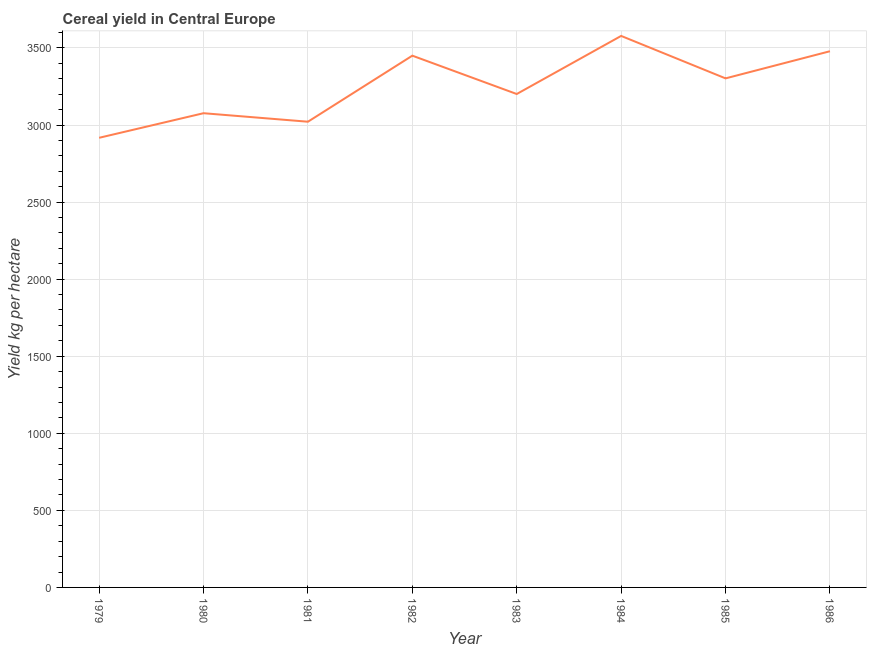What is the cereal yield in 1984?
Your answer should be very brief. 3578.03. Across all years, what is the maximum cereal yield?
Offer a very short reply. 3578.03. Across all years, what is the minimum cereal yield?
Your answer should be very brief. 2917.08. In which year was the cereal yield maximum?
Provide a succinct answer. 1984. In which year was the cereal yield minimum?
Your response must be concise. 1979. What is the sum of the cereal yield?
Make the answer very short. 2.60e+04. What is the difference between the cereal yield in 1983 and 1984?
Provide a short and direct response. -376.89. What is the average cereal yield per year?
Give a very brief answer. 3253.16. What is the median cereal yield?
Your response must be concise. 3251.85. What is the ratio of the cereal yield in 1981 to that in 1986?
Your answer should be compact. 0.87. Is the cereal yield in 1983 less than that in 1986?
Offer a terse response. Yes. What is the difference between the highest and the second highest cereal yield?
Ensure brevity in your answer.  99.38. What is the difference between the highest and the lowest cereal yield?
Give a very brief answer. 660.95. In how many years, is the cereal yield greater than the average cereal yield taken over all years?
Provide a succinct answer. 4. How many years are there in the graph?
Provide a succinct answer. 8. What is the difference between two consecutive major ticks on the Y-axis?
Give a very brief answer. 500. Does the graph contain grids?
Your answer should be very brief. Yes. What is the title of the graph?
Offer a terse response. Cereal yield in Central Europe. What is the label or title of the X-axis?
Your response must be concise. Year. What is the label or title of the Y-axis?
Provide a succinct answer. Yield kg per hectare. What is the Yield kg per hectare of 1979?
Make the answer very short. 2917.08. What is the Yield kg per hectare of 1980?
Your answer should be compact. 3076.56. What is the Yield kg per hectare in 1981?
Make the answer very short. 3021.36. What is the Yield kg per hectare in 1982?
Offer a very short reply. 3449.92. What is the Yield kg per hectare of 1983?
Your answer should be very brief. 3201.13. What is the Yield kg per hectare in 1984?
Provide a short and direct response. 3578.03. What is the Yield kg per hectare of 1985?
Provide a short and direct response. 3302.57. What is the Yield kg per hectare of 1986?
Offer a very short reply. 3478.65. What is the difference between the Yield kg per hectare in 1979 and 1980?
Your response must be concise. -159.48. What is the difference between the Yield kg per hectare in 1979 and 1981?
Offer a very short reply. -104.28. What is the difference between the Yield kg per hectare in 1979 and 1982?
Ensure brevity in your answer.  -532.84. What is the difference between the Yield kg per hectare in 1979 and 1983?
Offer a very short reply. -284.06. What is the difference between the Yield kg per hectare in 1979 and 1984?
Ensure brevity in your answer.  -660.95. What is the difference between the Yield kg per hectare in 1979 and 1985?
Offer a terse response. -385.49. What is the difference between the Yield kg per hectare in 1979 and 1986?
Make the answer very short. -561.57. What is the difference between the Yield kg per hectare in 1980 and 1981?
Your response must be concise. 55.2. What is the difference between the Yield kg per hectare in 1980 and 1982?
Ensure brevity in your answer.  -373.36. What is the difference between the Yield kg per hectare in 1980 and 1983?
Offer a terse response. -124.58. What is the difference between the Yield kg per hectare in 1980 and 1984?
Your answer should be very brief. -501.47. What is the difference between the Yield kg per hectare in 1980 and 1985?
Your answer should be compact. -226.01. What is the difference between the Yield kg per hectare in 1980 and 1986?
Your response must be concise. -402.09. What is the difference between the Yield kg per hectare in 1981 and 1982?
Your answer should be compact. -428.56. What is the difference between the Yield kg per hectare in 1981 and 1983?
Your answer should be compact. -179.77. What is the difference between the Yield kg per hectare in 1981 and 1984?
Keep it short and to the point. -556.66. What is the difference between the Yield kg per hectare in 1981 and 1985?
Make the answer very short. -281.21. What is the difference between the Yield kg per hectare in 1981 and 1986?
Ensure brevity in your answer.  -457.29. What is the difference between the Yield kg per hectare in 1982 and 1983?
Keep it short and to the point. 248.78. What is the difference between the Yield kg per hectare in 1982 and 1984?
Give a very brief answer. -128.11. What is the difference between the Yield kg per hectare in 1982 and 1985?
Offer a very short reply. 147.35. What is the difference between the Yield kg per hectare in 1982 and 1986?
Your answer should be very brief. -28.73. What is the difference between the Yield kg per hectare in 1983 and 1984?
Make the answer very short. -376.89. What is the difference between the Yield kg per hectare in 1983 and 1985?
Keep it short and to the point. -101.44. What is the difference between the Yield kg per hectare in 1983 and 1986?
Provide a succinct answer. -277.52. What is the difference between the Yield kg per hectare in 1984 and 1985?
Make the answer very short. 275.46. What is the difference between the Yield kg per hectare in 1984 and 1986?
Provide a short and direct response. 99.38. What is the difference between the Yield kg per hectare in 1985 and 1986?
Your response must be concise. -176.08. What is the ratio of the Yield kg per hectare in 1979 to that in 1980?
Provide a succinct answer. 0.95. What is the ratio of the Yield kg per hectare in 1979 to that in 1981?
Ensure brevity in your answer.  0.96. What is the ratio of the Yield kg per hectare in 1979 to that in 1982?
Provide a short and direct response. 0.85. What is the ratio of the Yield kg per hectare in 1979 to that in 1983?
Offer a very short reply. 0.91. What is the ratio of the Yield kg per hectare in 1979 to that in 1984?
Offer a terse response. 0.81. What is the ratio of the Yield kg per hectare in 1979 to that in 1985?
Offer a terse response. 0.88. What is the ratio of the Yield kg per hectare in 1979 to that in 1986?
Offer a very short reply. 0.84. What is the ratio of the Yield kg per hectare in 1980 to that in 1981?
Provide a succinct answer. 1.02. What is the ratio of the Yield kg per hectare in 1980 to that in 1982?
Make the answer very short. 0.89. What is the ratio of the Yield kg per hectare in 1980 to that in 1983?
Provide a short and direct response. 0.96. What is the ratio of the Yield kg per hectare in 1980 to that in 1984?
Offer a very short reply. 0.86. What is the ratio of the Yield kg per hectare in 1980 to that in 1985?
Provide a short and direct response. 0.93. What is the ratio of the Yield kg per hectare in 1980 to that in 1986?
Provide a short and direct response. 0.88. What is the ratio of the Yield kg per hectare in 1981 to that in 1982?
Give a very brief answer. 0.88. What is the ratio of the Yield kg per hectare in 1981 to that in 1983?
Offer a terse response. 0.94. What is the ratio of the Yield kg per hectare in 1981 to that in 1984?
Keep it short and to the point. 0.84. What is the ratio of the Yield kg per hectare in 1981 to that in 1985?
Make the answer very short. 0.92. What is the ratio of the Yield kg per hectare in 1981 to that in 1986?
Your answer should be very brief. 0.87. What is the ratio of the Yield kg per hectare in 1982 to that in 1983?
Your response must be concise. 1.08. What is the ratio of the Yield kg per hectare in 1982 to that in 1985?
Provide a short and direct response. 1.04. What is the ratio of the Yield kg per hectare in 1983 to that in 1984?
Keep it short and to the point. 0.9. What is the ratio of the Yield kg per hectare in 1983 to that in 1986?
Your answer should be very brief. 0.92. What is the ratio of the Yield kg per hectare in 1984 to that in 1985?
Ensure brevity in your answer.  1.08. What is the ratio of the Yield kg per hectare in 1985 to that in 1986?
Your response must be concise. 0.95. 